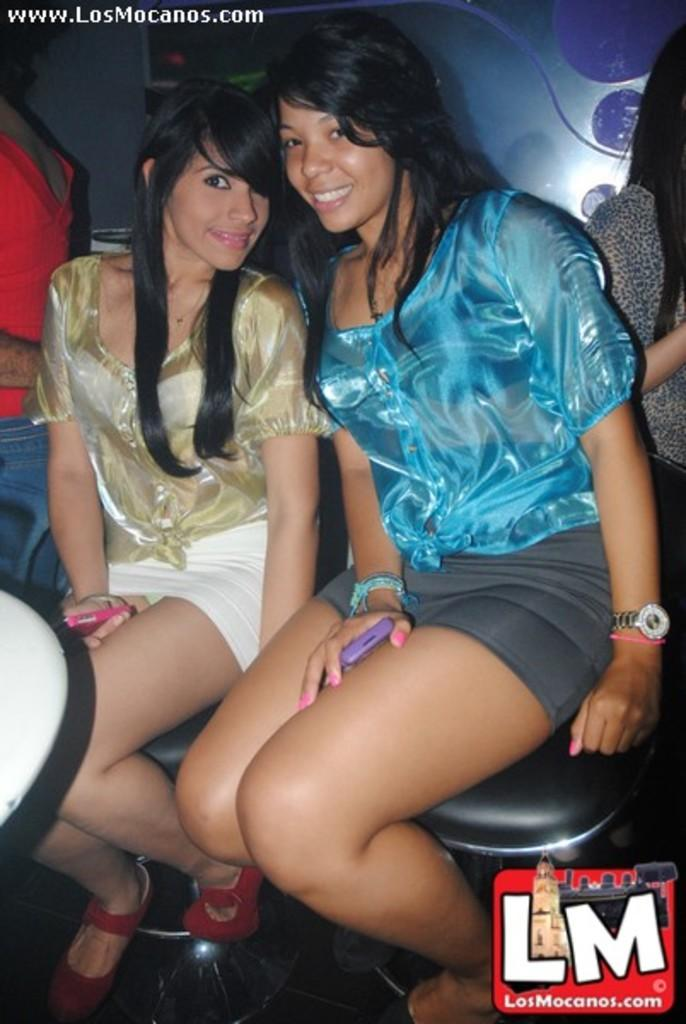How many women are in the image? There are two women in the image. What are the women doing in the image? The women are sitting on a platform and smiling. Can you describe the background of the image? There are people visible in the background of the image. What type of wing can be seen on the women in the image? There are no wings visible on the women in the image. Is there any grass present in the image? There is no grass visible in the image. 